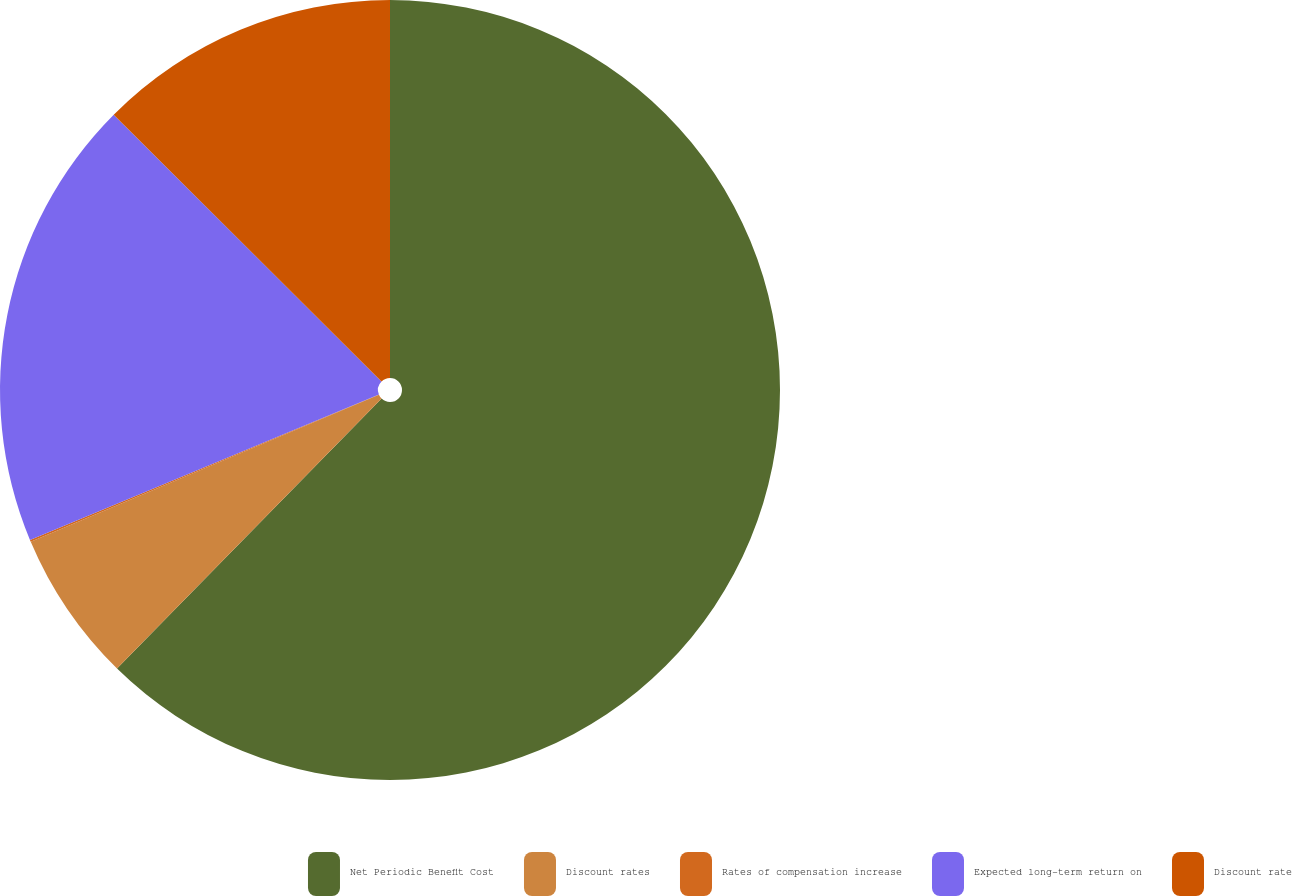Convert chart to OTSL. <chart><loc_0><loc_0><loc_500><loc_500><pie_chart><fcel>Net Periodic Benefit Cost<fcel>Discount rates<fcel>Rates of compensation increase<fcel>Expected long-term return on<fcel>Discount rate<nl><fcel>62.34%<fcel>6.3%<fcel>0.08%<fcel>18.75%<fcel>12.53%<nl></chart> 